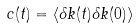Convert formula to latex. <formula><loc_0><loc_0><loc_500><loc_500>c ( t ) = \langle \delta k ( t ) \delta k ( 0 ) \rangle</formula> 